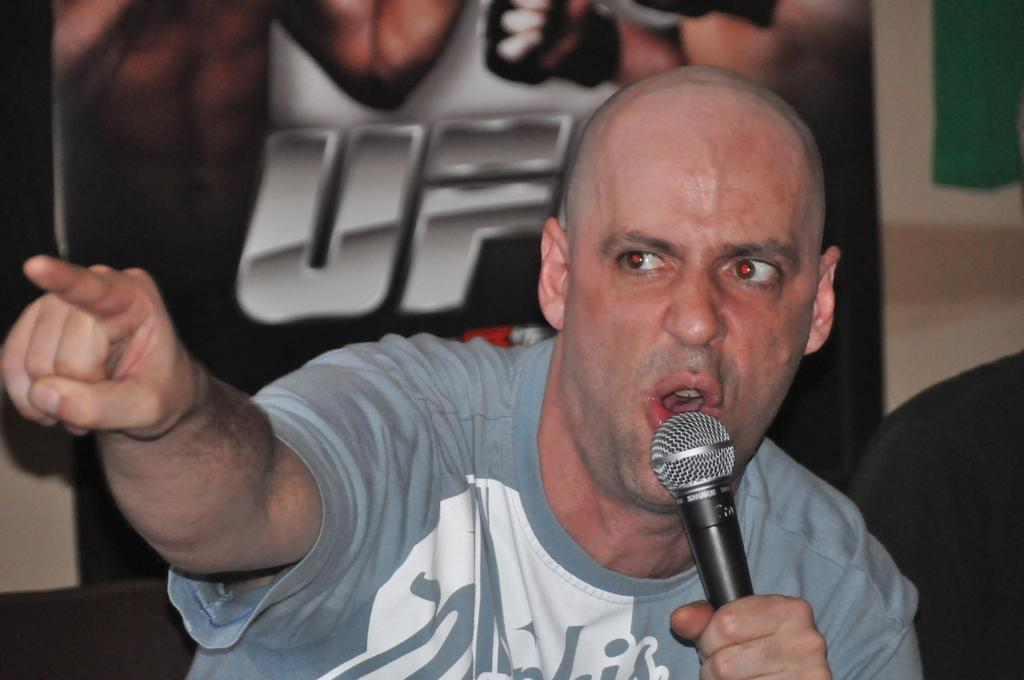Who is the main subject in the image? There is a man in the image. What is the man holding in the image? The man is holding a microphone. What is the man doing with the microphone? The man is speaking into the microphone. What type of owl can be seen perched on the man's shoulder in the image? There is no owl present in the image; the man is holding a microphone and speaking into it. 